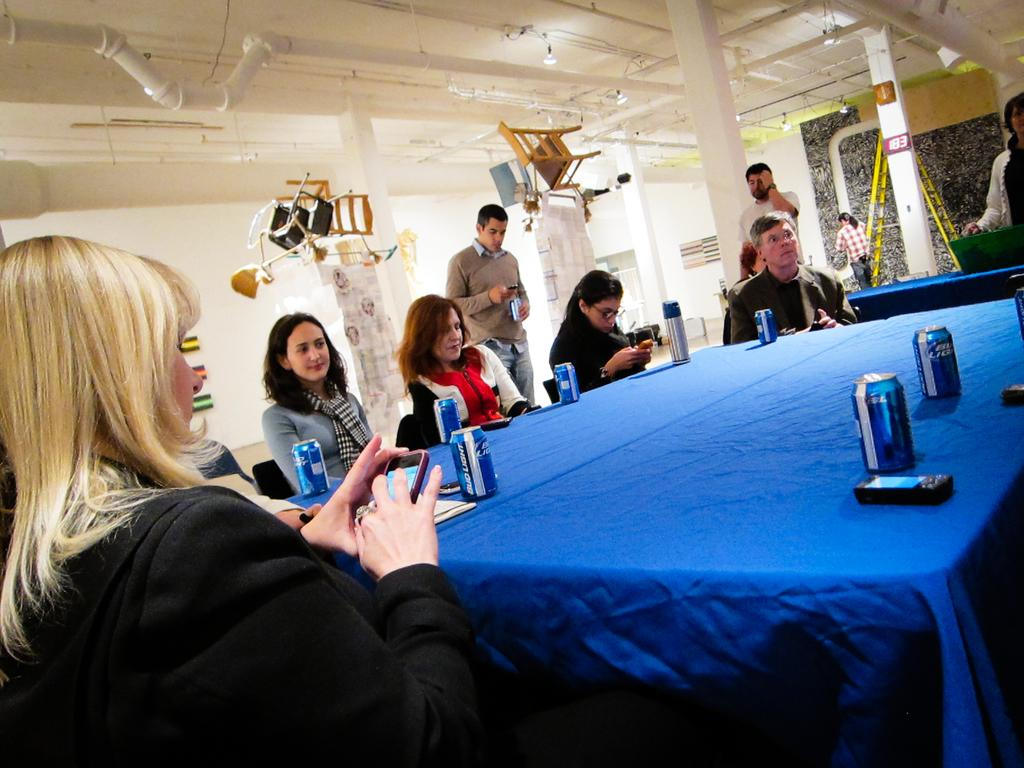How many people are in the image? There are six persons in the image. What are the persons doing in the image? The persons are sitting and looking at their phones. What type of squirrel can be seen playing volleyball in the image? There is no squirrel or volleyball present in the image. Is there a market visible in the image? No, there is no market visible in the image. 